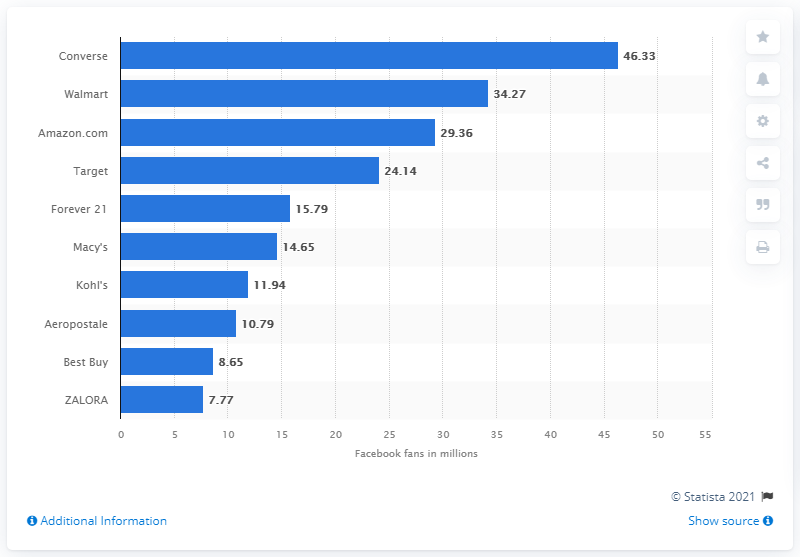Give some essential details in this illustration. As of June 2021, Converse is the most popular retail and consumer merchandise brand on Facebook, with the highest number of likes among all similar brands. Walmart has 34,270 Facebook fans. Converse has 46,330 fans on Facebook. Walmart, the world's largest retailer, is the second most popular retail brand on Facebook with over 34 million fans. 